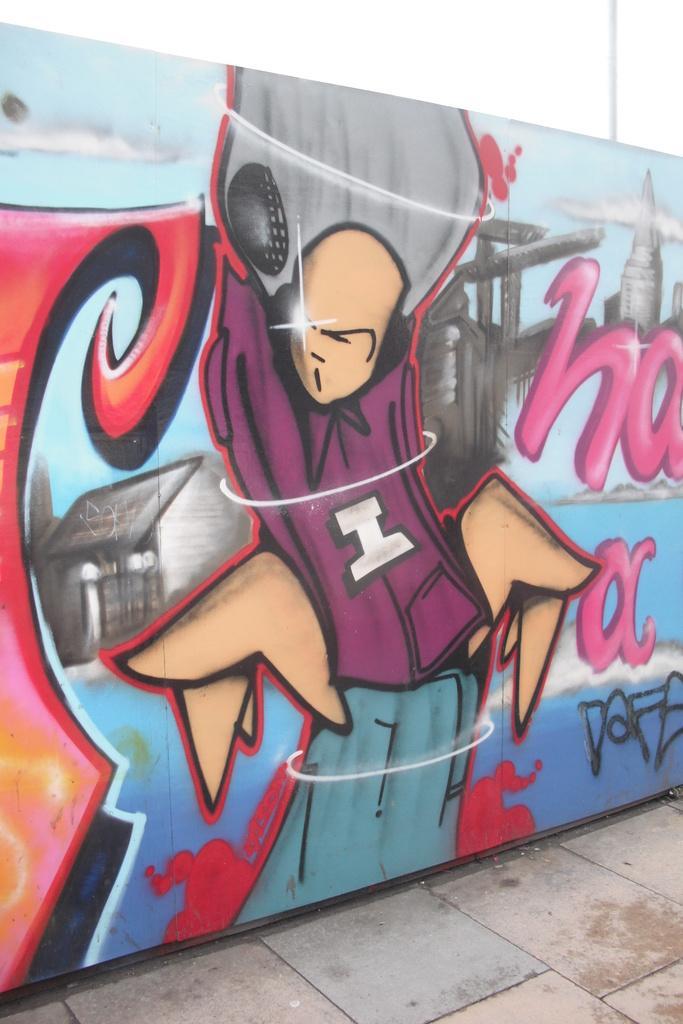Can you describe this image briefly? In this image, I can see a colorful graffiti painting on the wall. This looks like a road. 